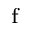Convert formula to latex. <formula><loc_0><loc_0><loc_500><loc_500>_ { f }</formula> 